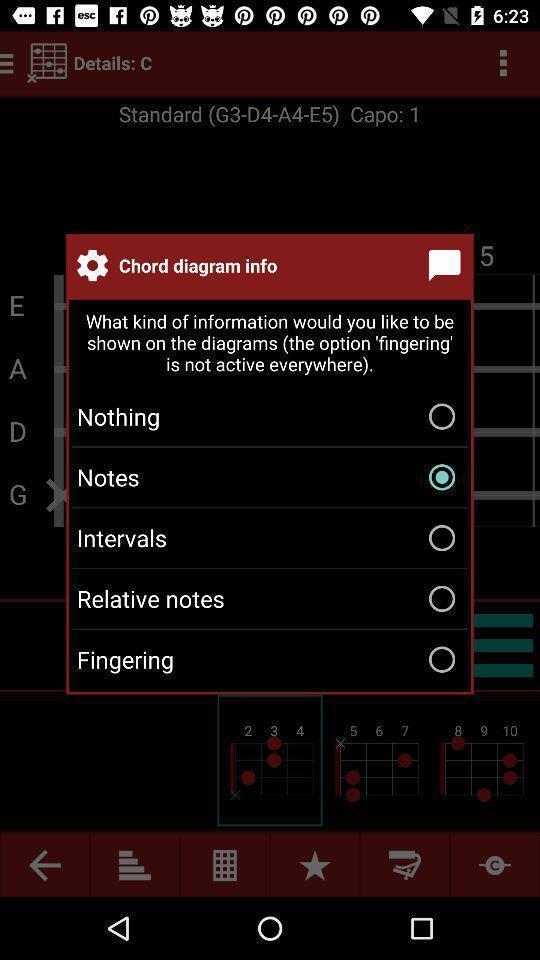Tell me what you see in this picture. Push up displaying for music app. 